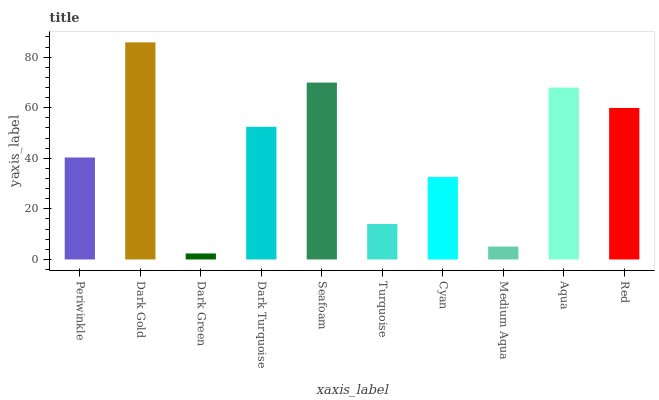Is Dark Green the minimum?
Answer yes or no. Yes. Is Dark Gold the maximum?
Answer yes or no. Yes. Is Dark Gold the minimum?
Answer yes or no. No. Is Dark Green the maximum?
Answer yes or no. No. Is Dark Gold greater than Dark Green?
Answer yes or no. Yes. Is Dark Green less than Dark Gold?
Answer yes or no. Yes. Is Dark Green greater than Dark Gold?
Answer yes or no. No. Is Dark Gold less than Dark Green?
Answer yes or no. No. Is Dark Turquoise the high median?
Answer yes or no. Yes. Is Periwinkle the low median?
Answer yes or no. Yes. Is Periwinkle the high median?
Answer yes or no. No. Is Dark Turquoise the low median?
Answer yes or no. No. 